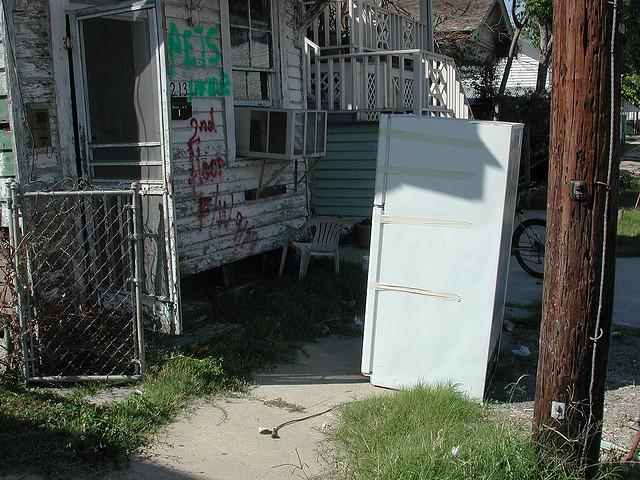Is this a junkyard?
Write a very short answer. No. Is there Graffiti in the image?
Be succinct. Yes. Does the grass need cut?
Be succinct. Yes. 